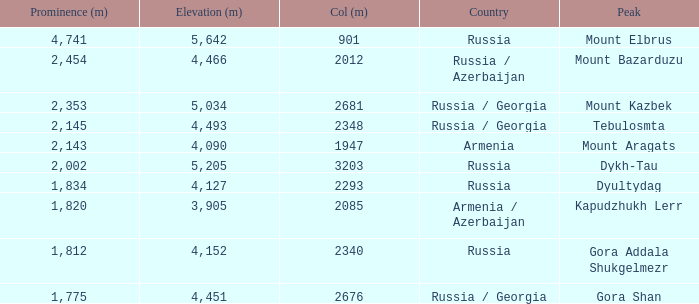What is the Elevation (m) of the Peak with a Prominence (m) larger than 2,143 and Col (m) of 2012? 4466.0. 